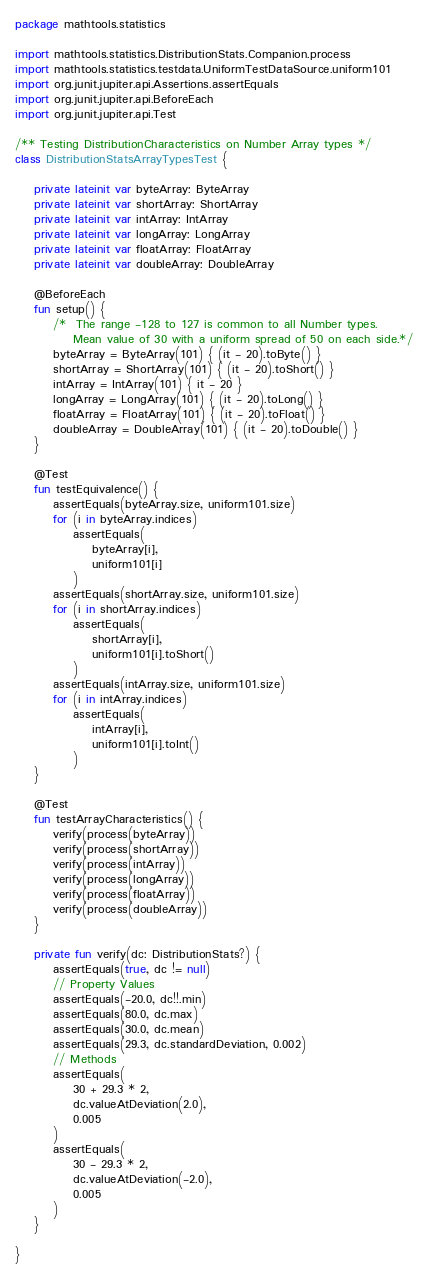Convert code to text. <code><loc_0><loc_0><loc_500><loc_500><_Kotlin_>package mathtools.statistics

import mathtools.statistics.DistributionStats.Companion.process
import mathtools.statistics.testdata.UniformTestDataSource.uniform101
import org.junit.jupiter.api.Assertions.assertEquals
import org.junit.jupiter.api.BeforeEach
import org.junit.jupiter.api.Test

/** Testing DistributionCharacteristics on Number Array types */
class DistributionStatsArrayTypesTest {

    private lateinit var byteArray: ByteArray
    private lateinit var shortArray: ShortArray
    private lateinit var intArray: IntArray
    private lateinit var longArray: LongArray
    private lateinit var floatArray: FloatArray
    private lateinit var doubleArray: DoubleArray

    @BeforeEach
    fun setup() {
        /*  The range -128 to 127 is common to all Number types.
            Mean value of 30 with a uniform spread of 50 on each side.*/
        byteArray = ByteArray(101) { (it - 20).toByte() }
        shortArray = ShortArray(101) { (it - 20).toShort() }
        intArray = IntArray(101) { it - 20 }
        longArray = LongArray(101) { (it - 20).toLong() }
        floatArray = FloatArray(101) { (it - 20).toFloat() }
        doubleArray = DoubleArray(101) { (it - 20).toDouble() }
    }

    @Test
    fun testEquivalence() {
        assertEquals(byteArray.size, uniform101.size)
        for (i in byteArray.indices)
            assertEquals(
                byteArray[i],
                uniform101[i]
            )
        assertEquals(shortArray.size, uniform101.size)
        for (i in shortArray.indices)
            assertEquals(
                shortArray[i],
                uniform101[i].toShort()
            )
        assertEquals(intArray.size, uniform101.size)
        for (i in intArray.indices)
            assertEquals(
                intArray[i],
                uniform101[i].toInt()
            )
    }

    @Test
    fun testArrayCharacteristics() {
        verify(process(byteArray))
        verify(process(shortArray))
        verify(process(intArray))
        verify(process(longArray))
        verify(process(floatArray))
        verify(process(doubleArray))
    }

    private fun verify(dc: DistributionStats?) {
        assertEquals(true, dc != null)
        // Property Values
        assertEquals(-20.0, dc!!.min)
        assertEquals(80.0, dc.max)
        assertEquals(30.0, dc.mean)
        assertEquals(29.3, dc.standardDeviation, 0.002)
        // Methods
        assertEquals(
            30 + 29.3 * 2,
            dc.valueAtDeviation(2.0),
            0.005
        )
        assertEquals(
            30 - 29.3 * 2,
            dc.valueAtDeviation(-2.0),
            0.005
        )
    }

}</code> 